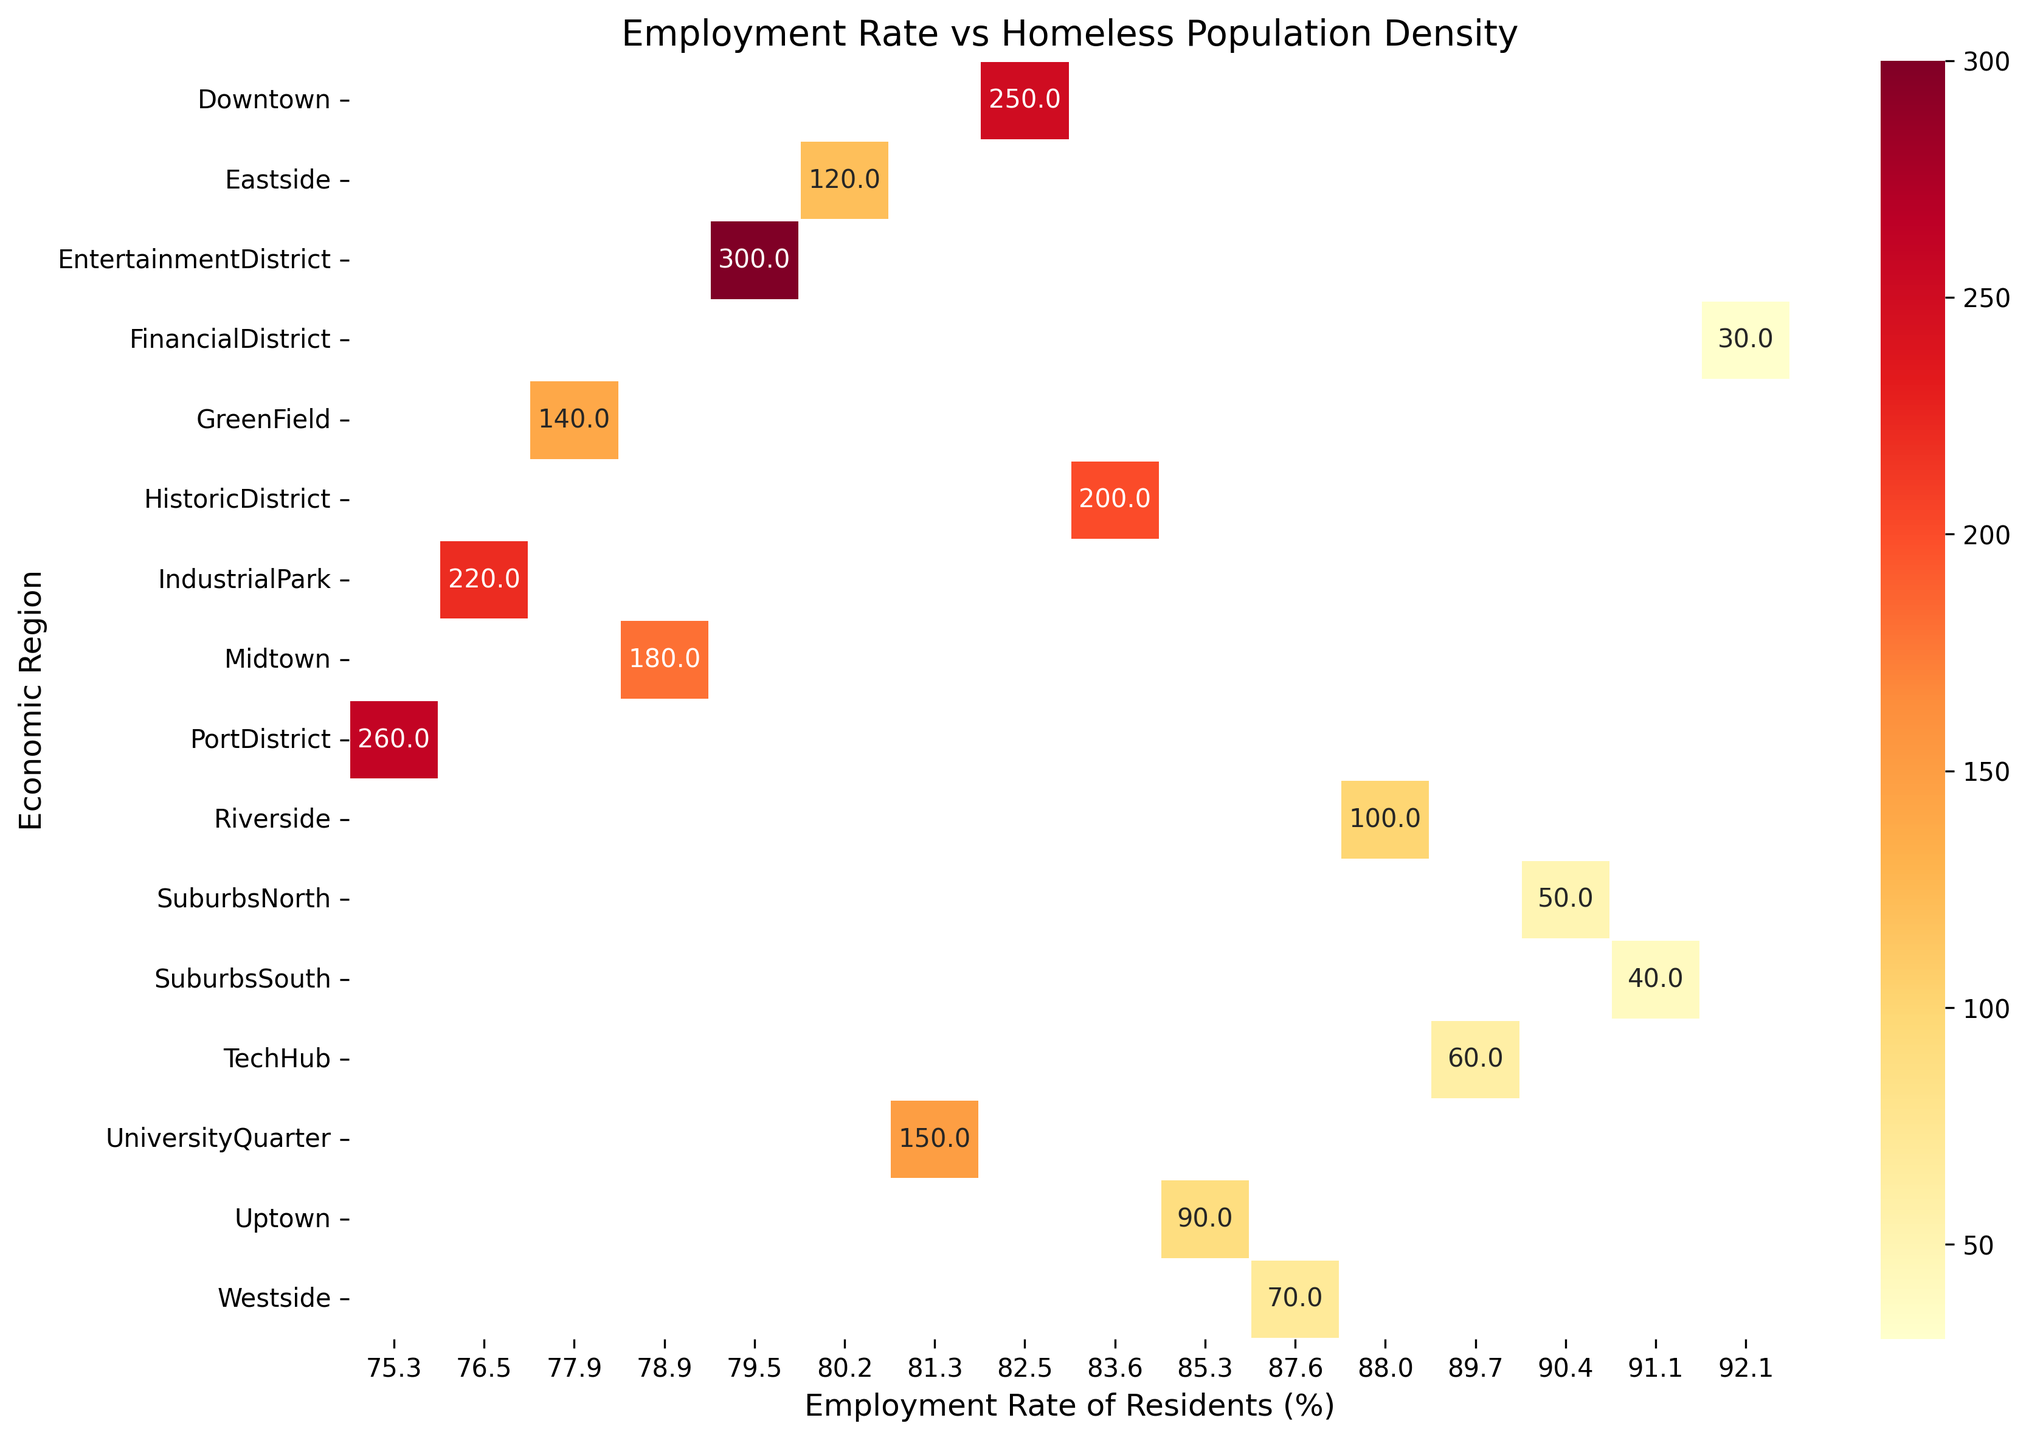Which economic region has the highest employment rate? To determine the economic region with the highest employment rate, locate the column with the highest value on the x-axis (Employment Rate of Residents) and identify the corresponding economic region from the y-axis (Economic Region).
Answer: FinancialDistrict Which region has the lowest employment rate, and what is its homeless population density? Identify the column with the lowest employment rate on the x-axis, which is 75.3%. Trace this to the corresponding economic region on the y-axis and note the value given for homeless population density in the heatmap.
Answer: PortDistrict, 260 Compare the homeless population densities of Downtown and PortDistrict. Which one is higher? Locate Downtown and PortDistrict on the y-axis. Compare their corresponding values on the heatmap. Downtown has a density of 250, while PortDistrict has 260.
Answer: PortDistrict In which economic region is the employment rate closest to 85%, and what is the homeless population density there? Locate the column closest to 85% on the x-axis. Check the corresponding economic region on the y-axis and note the homeless population density. The column closest to 85% employment rate is 85.3%, which corresponds to Uptown, with a homeless population density of 90.
Answer: Uptown, 90 How does the employment rate correlate with the homeless population density in IndustrialPark and Midtown? Locate IndustrialPark and Midtown on the y-axis. Compare their employment rates and homeless population densities. IndustrialPark has an employment rate of 76.5% and a homeless population density of 220. Midtown has an employment rate of 78.9% and a homeless population density of 180.
Answer: Both regions have lower employment rates and relatively high homeless population densities What is the combined homeless population density for the three regions with the highest employment rates? Identify the three regions with the highest employment rates: FinancialDistrict, SuburbsSouth, and SuburbsNorth. Sum their homeless population densities: FinancialDistrict (30), SuburbsSouth (40), and SuburbsNorth (50). The combined density is 30 + 40 + 50 = 120.
Answer: 120 Does the EntertainmentDistrict have the highest homeless population density? Locate the homeless population density for the EntertainmentDistrict on the heatmap and compare it with other regions. The EntertainmentDistrict has a population density of 300.
Answer: Yes Are there more regions with employment rates below or above 80%? Count the number of regions with employment rates below 80% and those above 80%.
Answer: More above 80% What is the median employment rate among all economic regions? List all the employment rates in ascending order and find the middle value. The employment rates are: 75.3, 76.5, 77.9, 78.9, 79.5, 80.2, 81.3, 82.5, 83.6, 85.3, 87.6, 88.0, 89.7, 90.4, 91.1, 92.1. The middle values are 82.5 and 83.6, so the median is (82.5 + 83.6) / 2 = 83.05.
Answer: 83.05 